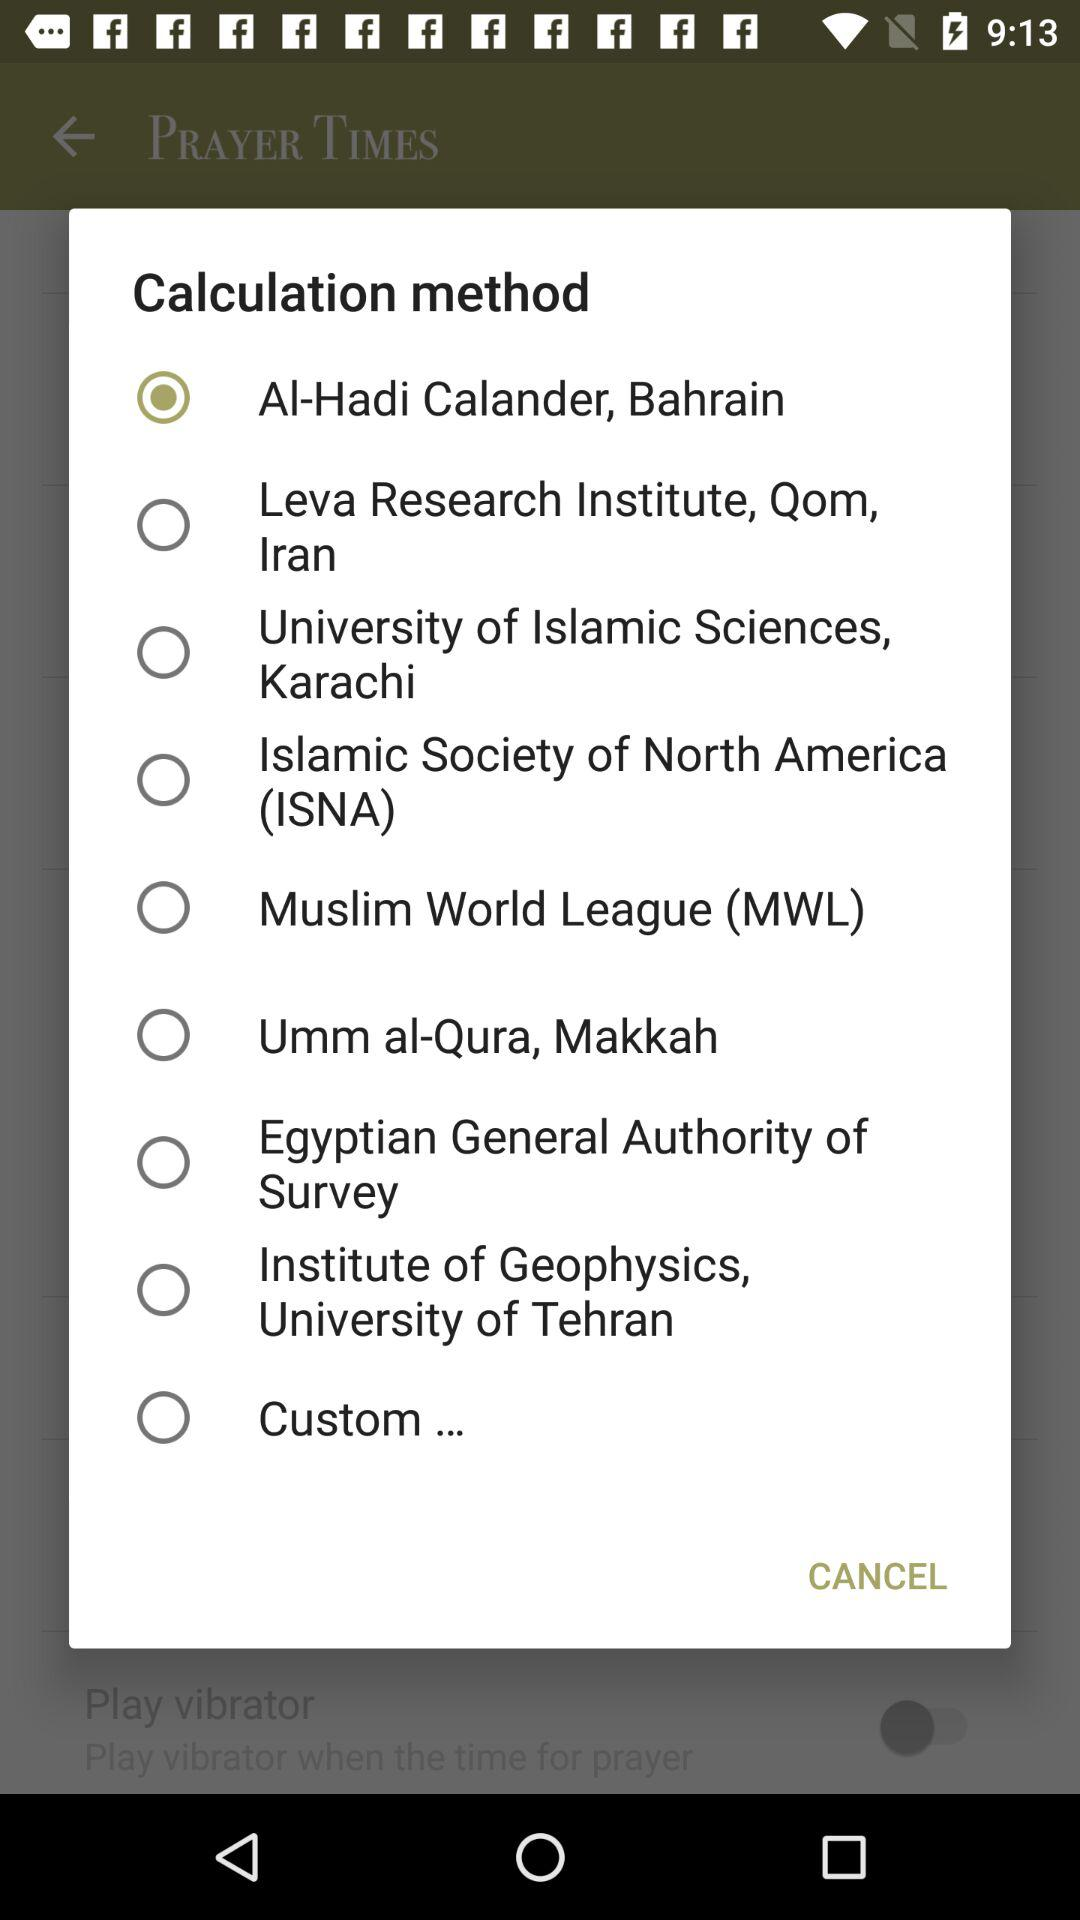Which calculation method is selected? The selected calculation method is "Al-Hadi Calander, Bahrain". 